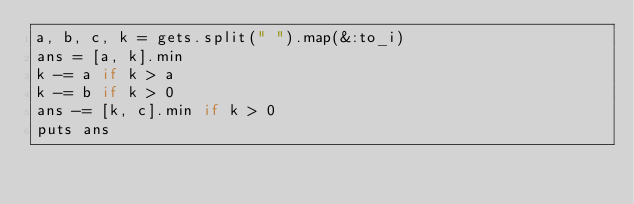<code> <loc_0><loc_0><loc_500><loc_500><_Ruby_>a, b, c, k = gets.split(" ").map(&:to_i)
ans = [a, k].min
k -= a if k > a
k -= b if k > 0
ans -= [k, c].min if k > 0
puts ans
</code> 